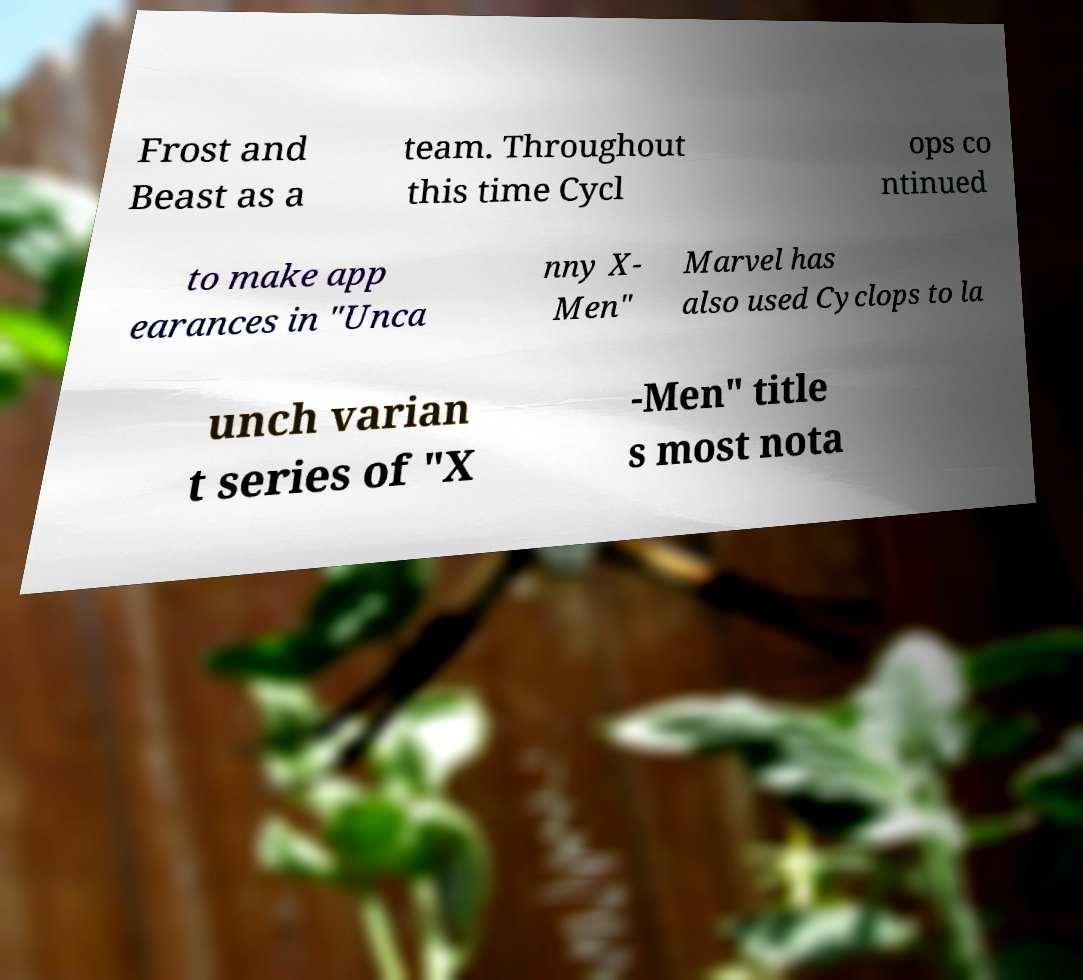Please identify and transcribe the text found in this image. Frost and Beast as a team. Throughout this time Cycl ops co ntinued to make app earances in "Unca nny X- Men" Marvel has also used Cyclops to la unch varian t series of "X -Men" title s most nota 